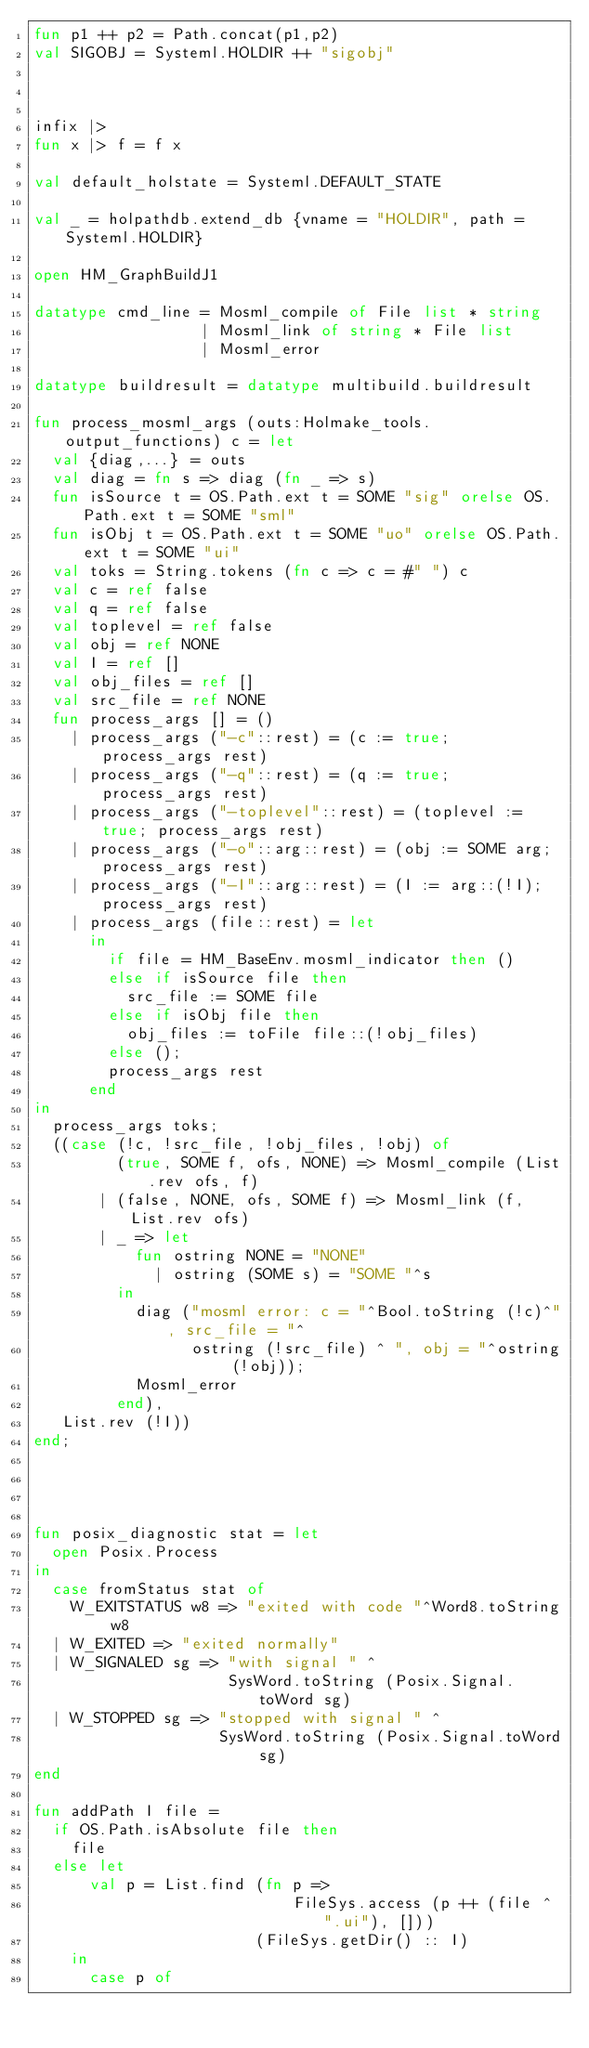Convert code to text. <code><loc_0><loc_0><loc_500><loc_500><_SML_>fun p1 ++ p2 = Path.concat(p1,p2)
val SIGOBJ = Systeml.HOLDIR ++ "sigobj"



infix |>
fun x |> f = f x

val default_holstate = Systeml.DEFAULT_STATE

val _ = holpathdb.extend_db {vname = "HOLDIR", path = Systeml.HOLDIR}

open HM_GraphBuildJ1

datatype cmd_line = Mosml_compile of File list * string
                  | Mosml_link of string * File list
                  | Mosml_error

datatype buildresult = datatype multibuild.buildresult

fun process_mosml_args (outs:Holmake_tools.output_functions) c = let
  val {diag,...} = outs
  val diag = fn s => diag (fn _ => s)
  fun isSource t = OS.Path.ext t = SOME "sig" orelse OS.Path.ext t = SOME "sml"
  fun isObj t = OS.Path.ext t = SOME "uo" orelse OS.Path.ext t = SOME "ui"
  val toks = String.tokens (fn c => c = #" ") c
  val c = ref false
  val q = ref false
  val toplevel = ref false
  val obj = ref NONE
  val I = ref []
  val obj_files = ref []
  val src_file = ref NONE
  fun process_args [] = ()
    | process_args ("-c"::rest) = (c := true; process_args rest)
    | process_args ("-q"::rest) = (q := true; process_args rest)
    | process_args ("-toplevel"::rest) = (toplevel := true; process_args rest)
    | process_args ("-o"::arg::rest) = (obj := SOME arg; process_args rest)
    | process_args ("-I"::arg::rest) = (I := arg::(!I); process_args rest)
    | process_args (file::rest) = let
      in
        if file = HM_BaseEnv.mosml_indicator then ()
        else if isSource file then
          src_file := SOME file
        else if isObj file then
          obj_files := toFile file::(!obj_files)
        else ();
        process_args rest
      end
in
  process_args toks;
  ((case (!c, !src_file, !obj_files, !obj) of
         (true, SOME f, ofs, NONE) => Mosml_compile (List.rev ofs, f)
       | (false, NONE, ofs, SOME f) => Mosml_link (f, List.rev ofs)
       | _ => let
           fun ostring NONE = "NONE"
             | ostring (SOME s) = "SOME "^s
         in
           diag ("mosml error: c = "^Bool.toString (!c)^", src_file = "^
                 ostring (!src_file) ^ ", obj = "^ostring (!obj));
           Mosml_error
         end),
   List.rev (!I))
end;




fun posix_diagnostic stat = let
  open Posix.Process
in
  case fromStatus stat of
    W_EXITSTATUS w8 => "exited with code "^Word8.toString w8
  | W_EXITED => "exited normally"
  | W_SIGNALED sg => "with signal " ^
                     SysWord.toString (Posix.Signal.toWord sg)
  | W_STOPPED sg => "stopped with signal " ^
                    SysWord.toString (Posix.Signal.toWord sg)
end

fun addPath I file =
  if OS.Path.isAbsolute file then
    file
  else let
      val p = List.find (fn p =>
                            FileSys.access (p ++ (file ^ ".ui"), []))
                        (FileSys.getDir() :: I)
    in
      case p of</code> 